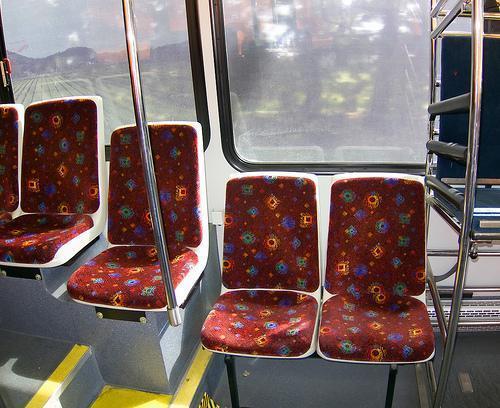How many windows are in the photo?
Give a very brief answer. 2. How many people are sitting on the chairs?
Give a very brief answer. 0. 